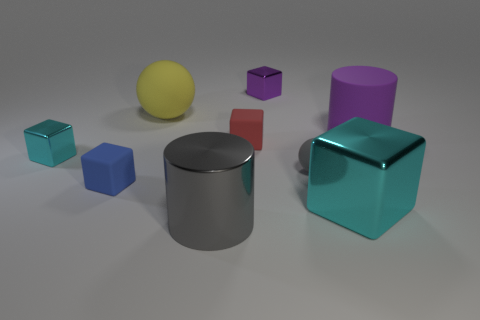Subtract all big blocks. How many blocks are left? 4 Subtract all red spheres. How many cyan blocks are left? 2 Add 1 large matte spheres. How many objects exist? 10 Subtract all purple blocks. How many blocks are left? 4 Subtract all spheres. How many objects are left? 7 Add 4 tiny rubber things. How many tiny rubber things are left? 7 Add 2 big cyan metal objects. How many big cyan metal objects exist? 3 Subtract 1 gray spheres. How many objects are left? 8 Subtract all brown blocks. Subtract all cyan cylinders. How many blocks are left? 5 Subtract all tiny purple cubes. Subtract all small balls. How many objects are left? 7 